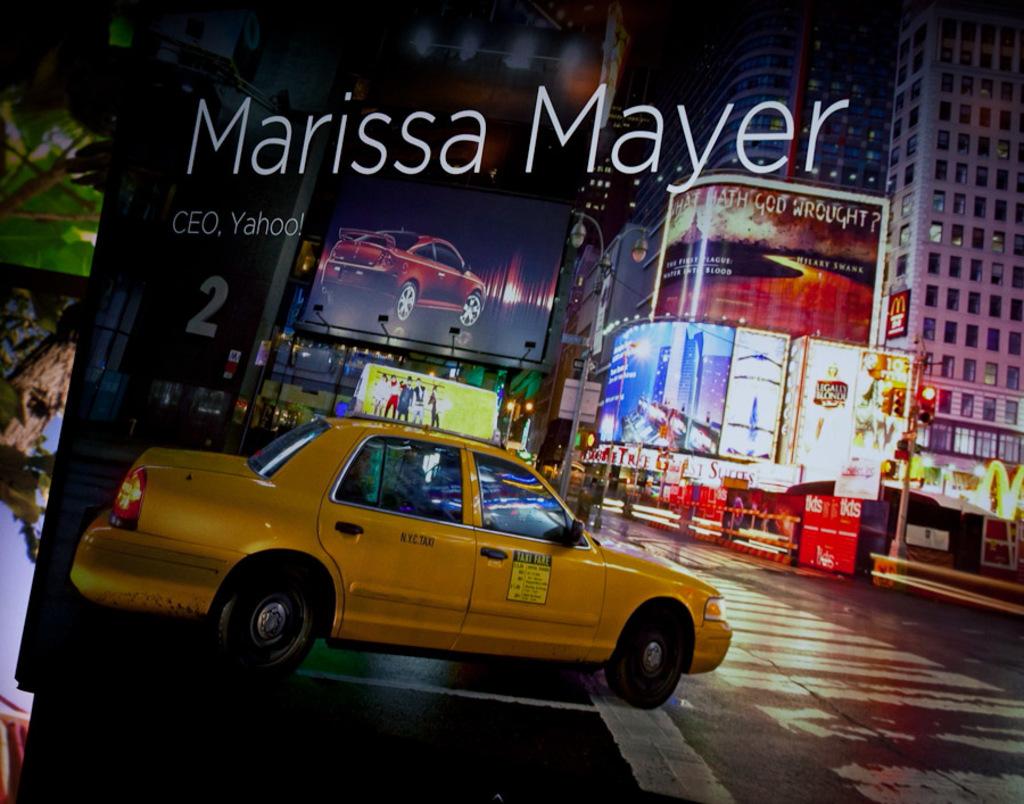What city is the taxi from?
Ensure brevity in your answer.  Nyc. Who is the ceo of yahoo!?
Offer a terse response. Marissa mayer. 